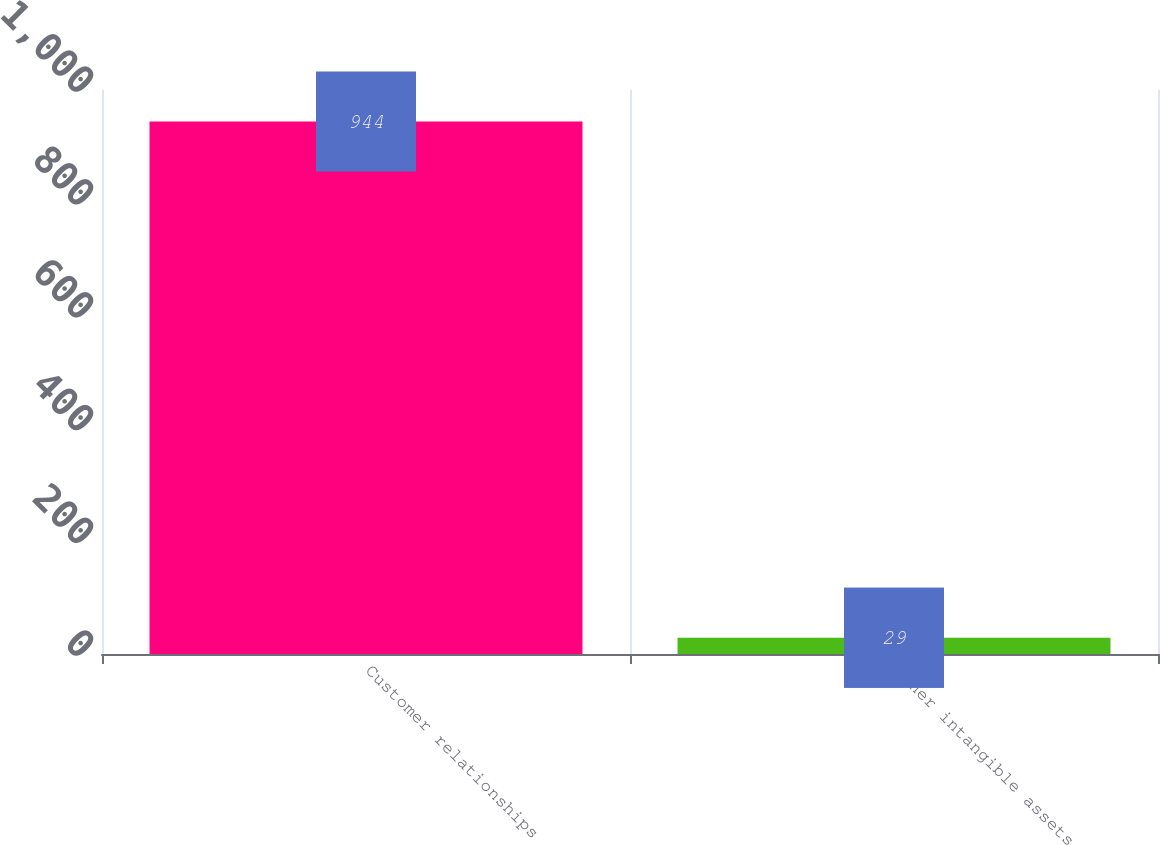Convert chart. <chart><loc_0><loc_0><loc_500><loc_500><bar_chart><fcel>Customer relationships<fcel>Other intangible assets<nl><fcel>944<fcel>29<nl></chart> 